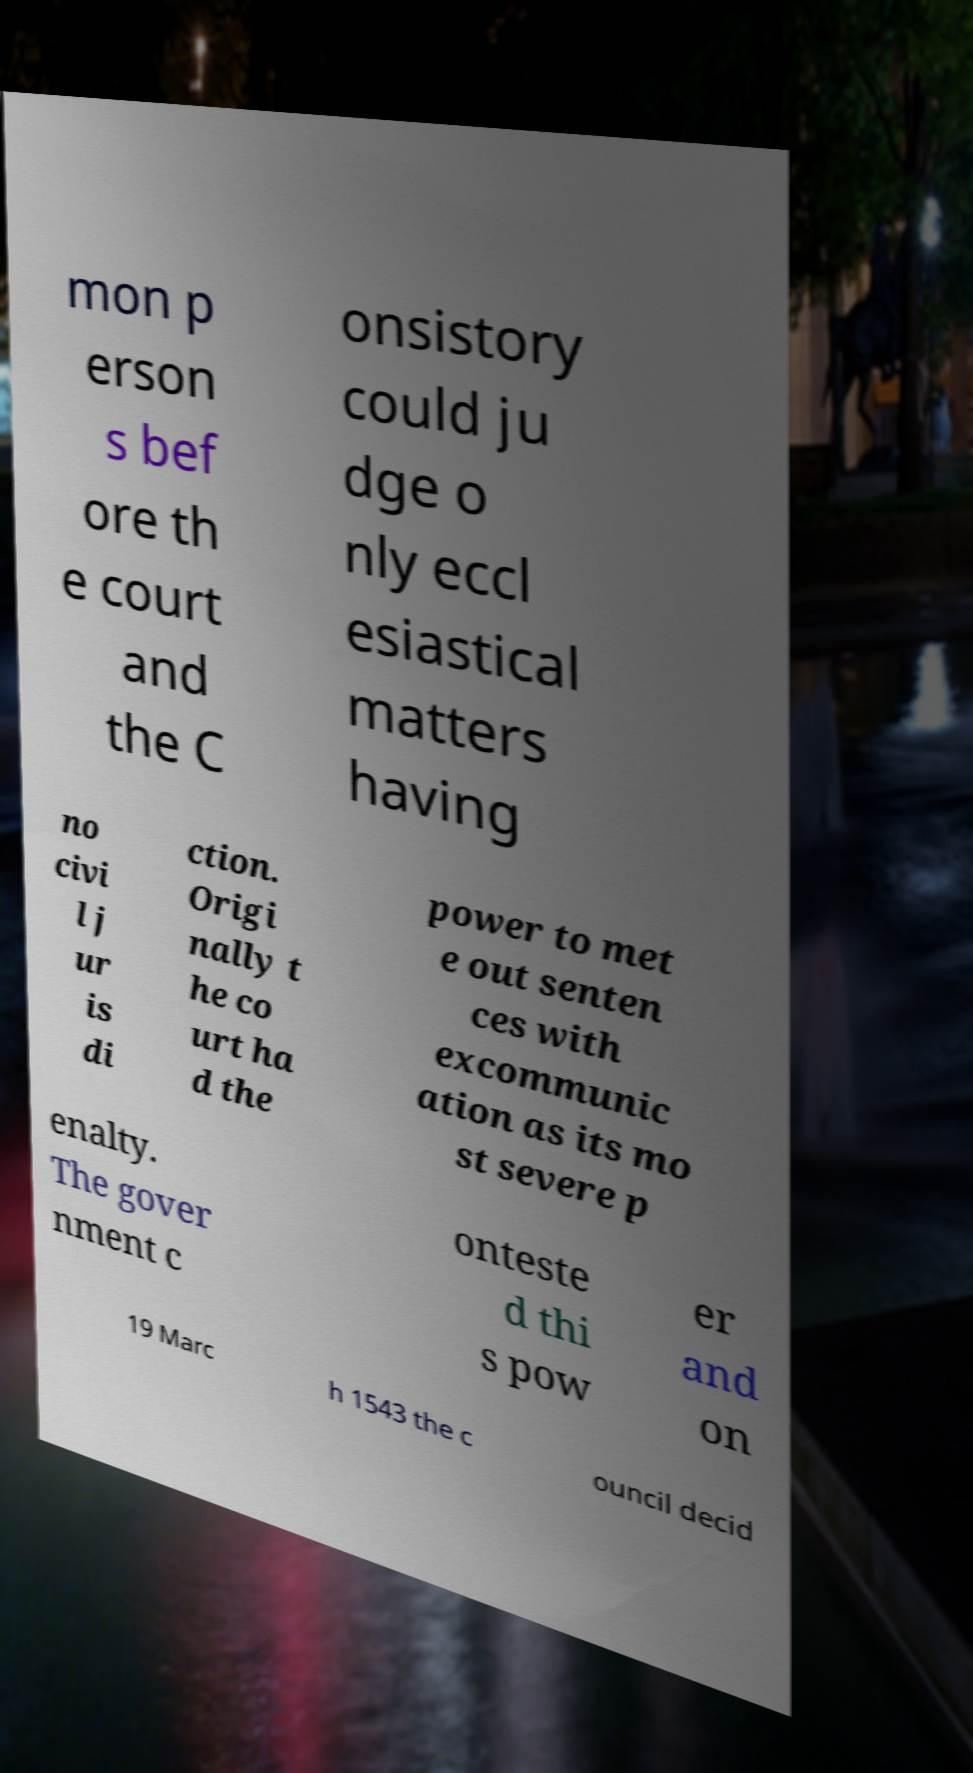What messages or text are displayed in this image? I need them in a readable, typed format. mon p erson s bef ore th e court and the C onsistory could ju dge o nly eccl esiastical matters having no civi l j ur is di ction. Origi nally t he co urt ha d the power to met e out senten ces with excommunic ation as its mo st severe p enalty. The gover nment c onteste d thi s pow er and on 19 Marc h 1543 the c ouncil decid 